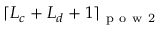<formula> <loc_0><loc_0><loc_500><loc_500>\lceil L _ { c } + L _ { d } + 1 \rceil _ { p o w 2 }</formula> 